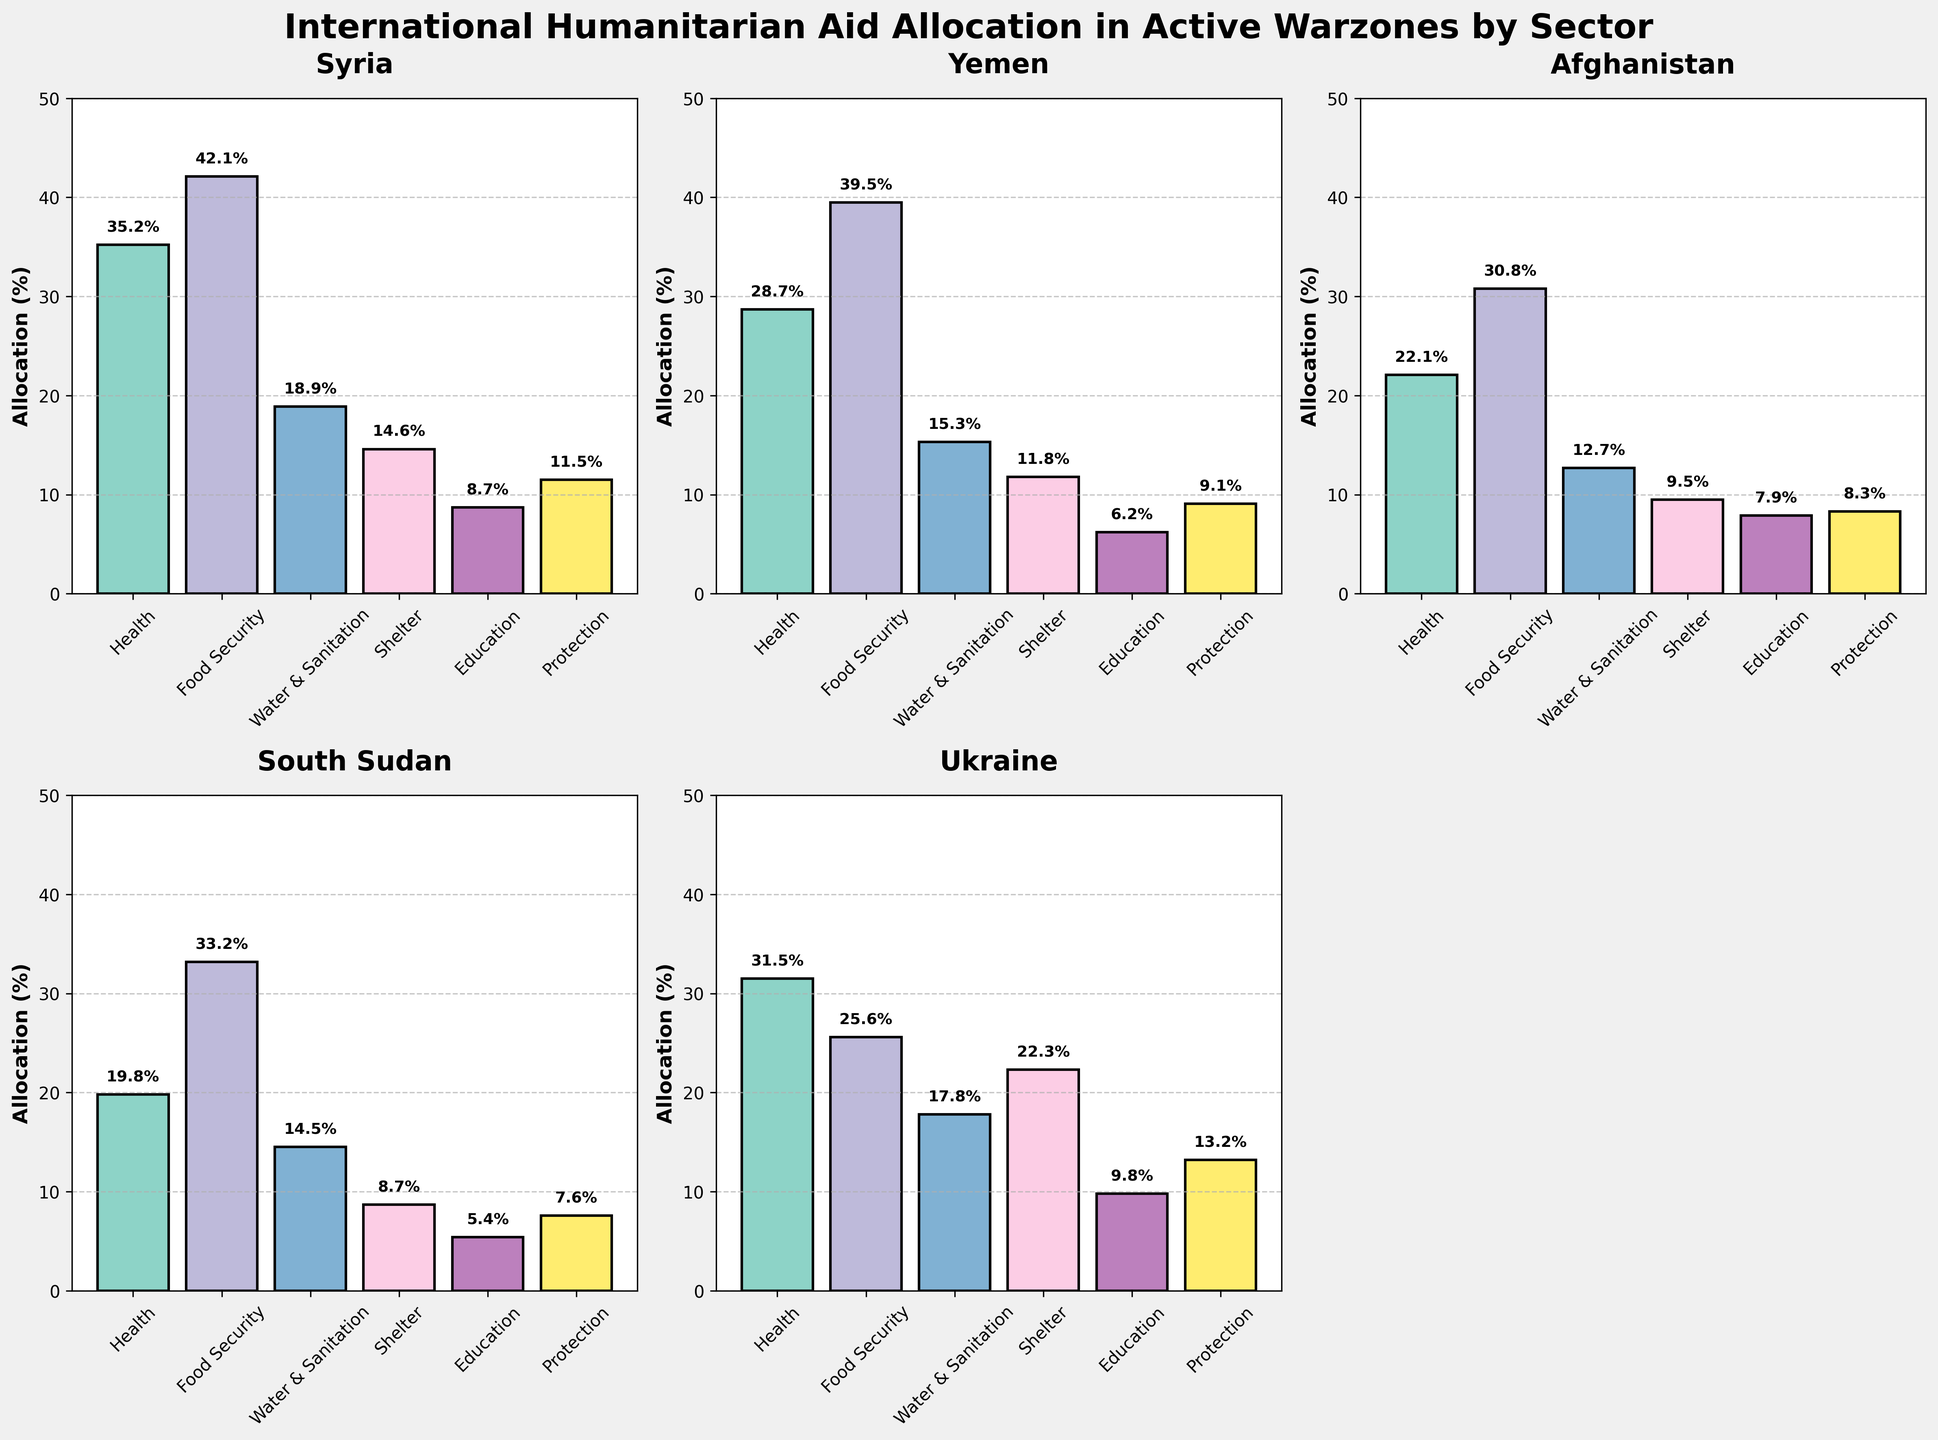What are the main sectors illustrated in the subplots? The main sectors are displayed on the x-axis in each subplot. These sectors are Health, Food Security, Water & Sanitation, Shelter, Education, and Protection.
Answer: Health, Food Security, Water & Sanitation, Shelter, Education, Protection Which country has the highest allocation in the Food Security sector? By looking at each subplot, identify the country with the highest bar in the Food Security sector. The highest allocation is represented in the Syria subplot.
Answer: Syria How does Ukraine's allocation in the Shelter sector compare to Syria's allocation in the same sector? In the Ukraine subplot, the bar for Shelter is at 22.3%. In the Syria subplot, the bar for Shelter is at 14.6%. By comparing these two values, Ukraine has a higher allocation than Syria.
Answer: Ukraine has a higher allocation What is the average aid allocation percentage for the Health sector across the five countries? Sum the Health sector percentages across Syria, Yemen, Afghanistan, South Sudan, and Ukraine: 35.2 + 28.7 + 22.1 + 19.8 + 31.5 = 137.3. Divide by the number of countries (5) to find the average: 137.3 / 5 = 27.46%
Answer: 27.46% In which sector and country does the lowest allocation percentage appear? Scan each subplot to find the smallest bar in any sector. Afghanistan’s allocation in Shelter is the lowest at 8.7%.
Answer: Shelter in Afghanistan Which sector in South Sudan has the highest allocation? By observing the South Sudan subplot, the highest bar represents Food Security at 33.2%.
Answer: Food Security Compare the Protection allocation between Yemen and Ukraine. Which country has a higher allocation? In the Yemen subplot, the Protection sector bar is at 9.1%. In the Ukraine subplot, it is at 13.2%. Therefore, Ukraine has a higher allocation for Protection.
Answer: Ukraine Calculate the difference in Food Security allocation between Syria and Afghanistan. Syria has a Food Security allocation of 42.1% while Afghanistan has 30.8%. The difference is calculated as 42.1 - 30.8 = 11.3%.
Answer: 11.3% What is the total allocation percentage for the Education sector across all countries? Sum the Education percentages: 8.7 (Syria) + 6.2 (Yemen) + 7.9 (Afghanistan) + 5.4 (South Sudan) + 9.8 (Ukraine) = 38
Answer: 38% How does the Water & Sanitation sector allocation in Yemen compare to the Health sector allocation in South Sudan? Yemen has a Water & Sanitation allocation of 15.3%, and South Sudan has a Health allocation of 19.8%. Comparing these two, South Sudan has a higher allocation in Health.
Answer: South Sudan's Health is higher 